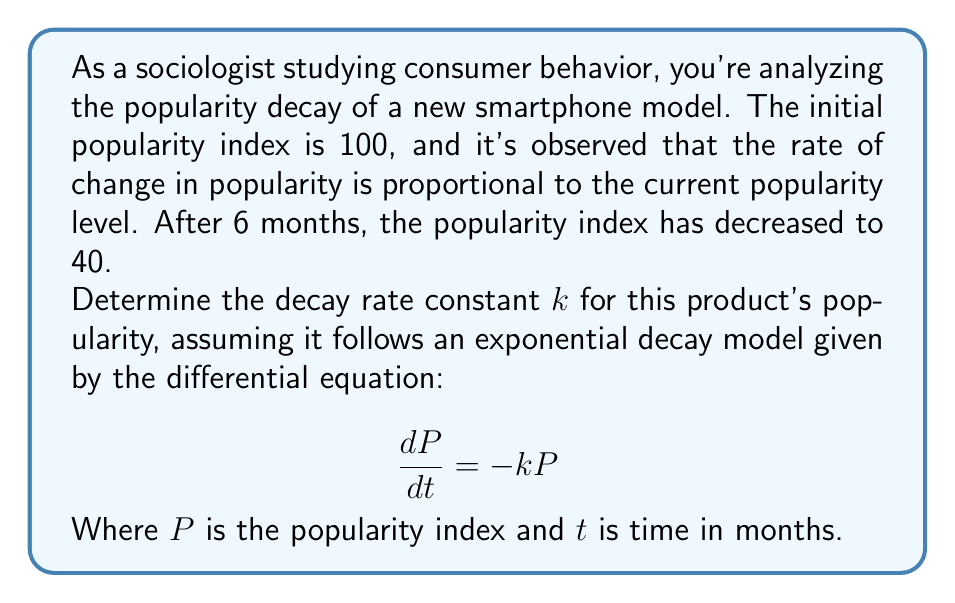Teach me how to tackle this problem. Let's solve this step-by-step:

1) The general solution for the exponential decay model is:
   $$P(t) = P_0e^{-kt}$$
   where $P_0$ is the initial popularity.

2) We know:
   - Initial popularity $P_0 = 100$
   - At $t = 6$ months, $P(6) = 40$

3) Substituting these values into the general solution:
   $$40 = 100e^{-6k}$$

4) Dividing both sides by 100:
   $$0.4 = e^{-6k}$$

5) Taking the natural logarithm of both sides:
   $$\ln(0.4) = -6k$$

6) Solving for $k$:
   $$k = -\frac{\ln(0.4)}{6}$$

7) Calculate the value:
   $$k = -\frac{\ln(0.4)}{6} \approx 0.1534$$

Therefore, the decay rate constant $k$ is approximately 0.1534 per month.
Answer: $k \approx 0.1534$ per month 